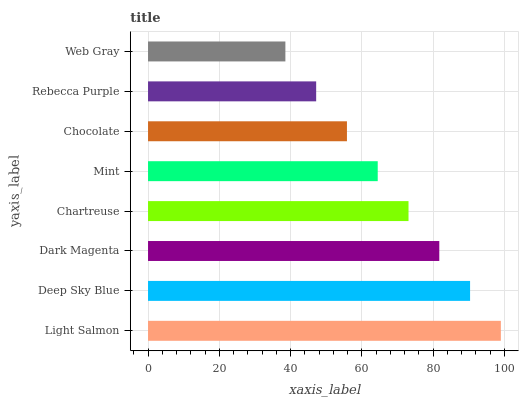Is Web Gray the minimum?
Answer yes or no. Yes. Is Light Salmon the maximum?
Answer yes or no. Yes. Is Deep Sky Blue the minimum?
Answer yes or no. No. Is Deep Sky Blue the maximum?
Answer yes or no. No. Is Light Salmon greater than Deep Sky Blue?
Answer yes or no. Yes. Is Deep Sky Blue less than Light Salmon?
Answer yes or no. Yes. Is Deep Sky Blue greater than Light Salmon?
Answer yes or no. No. Is Light Salmon less than Deep Sky Blue?
Answer yes or no. No. Is Chartreuse the high median?
Answer yes or no. Yes. Is Mint the low median?
Answer yes or no. Yes. Is Dark Magenta the high median?
Answer yes or no. No. Is Chartreuse the low median?
Answer yes or no. No. 